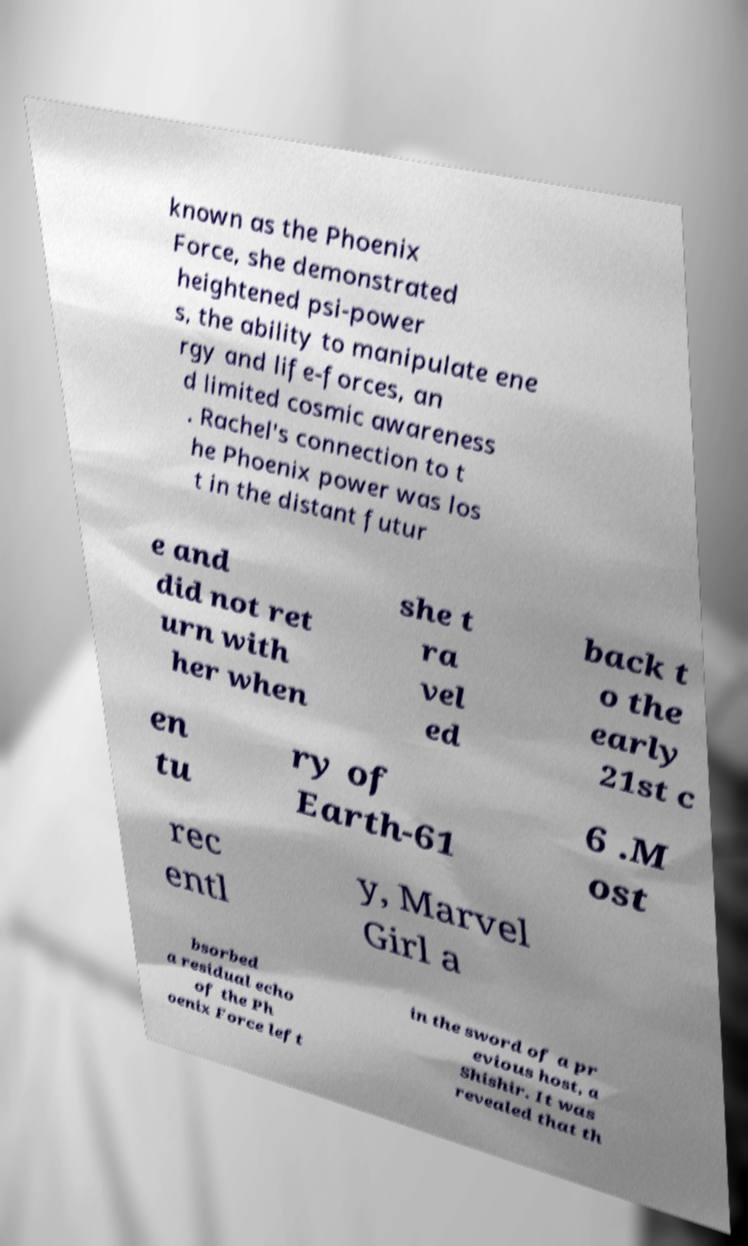I need the written content from this picture converted into text. Can you do that? known as the Phoenix Force, she demonstrated heightened psi-power s, the ability to manipulate ene rgy and life-forces, an d limited cosmic awareness . Rachel's connection to t he Phoenix power was los t in the distant futur e and did not ret urn with her when she t ra vel ed back t o the early 21st c en tu ry of Earth-61 6 .M ost rec entl y, Marvel Girl a bsorbed a residual echo of the Ph oenix Force left in the sword of a pr evious host, a Shishir. It was revealed that th 